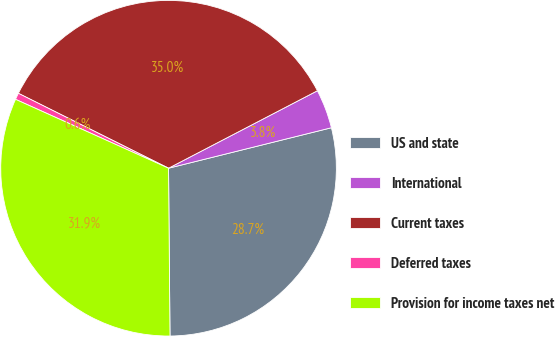Convert chart to OTSL. <chart><loc_0><loc_0><loc_500><loc_500><pie_chart><fcel>US and state<fcel>International<fcel>Current taxes<fcel>Deferred taxes<fcel>Provision for income taxes net<nl><fcel>28.74%<fcel>3.76%<fcel>35.0%<fcel>0.63%<fcel>31.87%<nl></chart> 